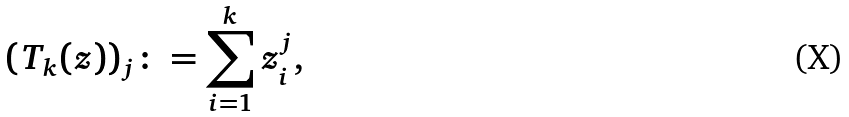<formula> <loc_0><loc_0><loc_500><loc_500>( T _ { k } ( z ) ) _ { j } \colon = \sum _ { i = 1 } ^ { k } z _ { i } ^ { j } ,</formula> 